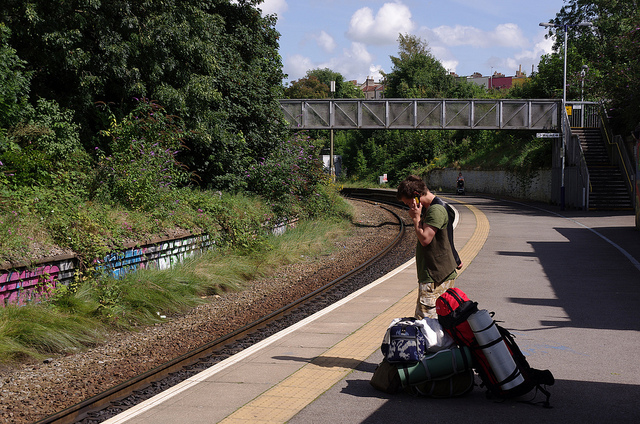Imagine this scene taking place in a fictional, magical world. What fantastical elements would you add? In a fictional, magical world, the train station would be bustling with mythical creatures like elves and dwarves. The overhead bridge could be adorned with glowing runes that provide light and protection to those who cross. The train tracks themselves might hum with an otherworldly energy, and the trains could be steam-powered dragons that carry passengers to far-off enchanted lands. 